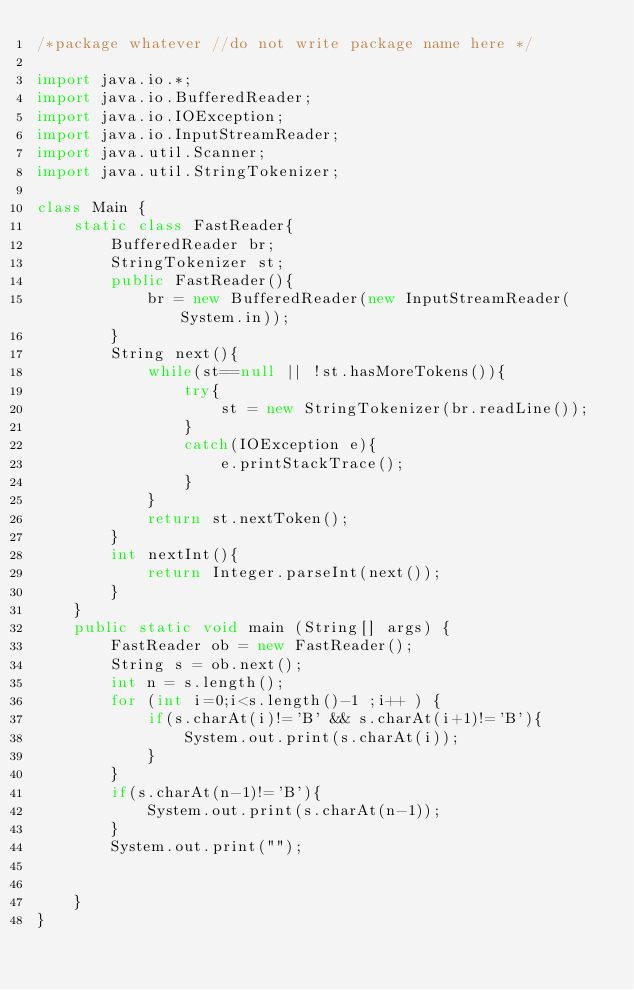<code> <loc_0><loc_0><loc_500><loc_500><_Java_>/*package whatever //do not write package name here */

import java.io.*;
import java.io.BufferedReader; 
import java.io.IOException; 
import java.io.InputStreamReader; 
import java.util.Scanner; 
import java.util.StringTokenizer; 

class Main {
    static class FastReader{
        BufferedReader br;
        StringTokenizer st;
        public FastReader(){
            br = new BufferedReader(new InputStreamReader(System.in));
        }
        String next(){
            while(st==null || !st.hasMoreTokens()){
                try{
                    st = new StringTokenizer(br.readLine());
                }
                catch(IOException e){
                    e.printStackTrace();
                }
            }
            return st.nextToken();
        }
        int nextInt(){
            return Integer.parseInt(next());
        }
    }
	public static void main (String[] args) {
		FastReader ob = new FastReader();
		String s = ob.next();
		int n = s.length();
		for (int i=0;i<s.length()-1 ;i++ ) {
		    if(s.charAt(i)!='B' && s.charAt(i+1)!='B'){
		        System.out.print(s.charAt(i));
		    }
		}
		if(s.charAt(n-1)!='B'){
		    System.out.print(s.charAt(n-1));
		}
		System.out.print("");
		
	
	}
}</code> 